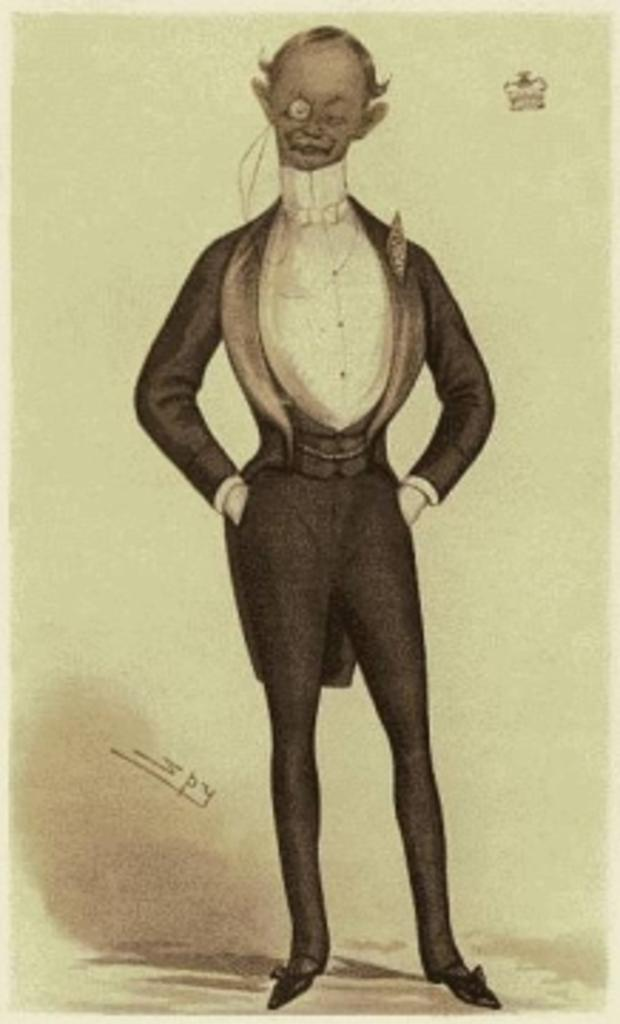What type of artwork is shown in the image? The image is a painting. What is the main subject of the painting? There is a demon depicted in the painting. What type of bird can be seen perched on the cactus in the image? There is no bird or cactus present in the image; it is a painting of a demon. Can you describe the veins on the demon's wings in the image? The image does not show the demon's wings, so we cannot describe any veins on them. 